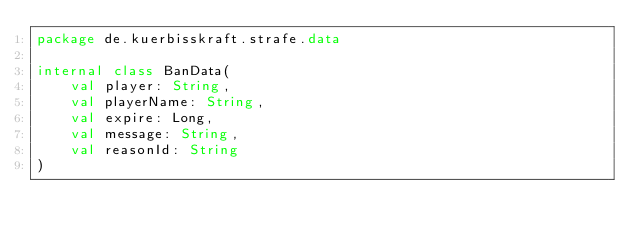<code> <loc_0><loc_0><loc_500><loc_500><_Kotlin_>package de.kuerbisskraft.strafe.data

internal class BanData(
    val player: String,
    val playerName: String,
    val expire: Long,
    val message: String,
    val reasonId: String
)
</code> 